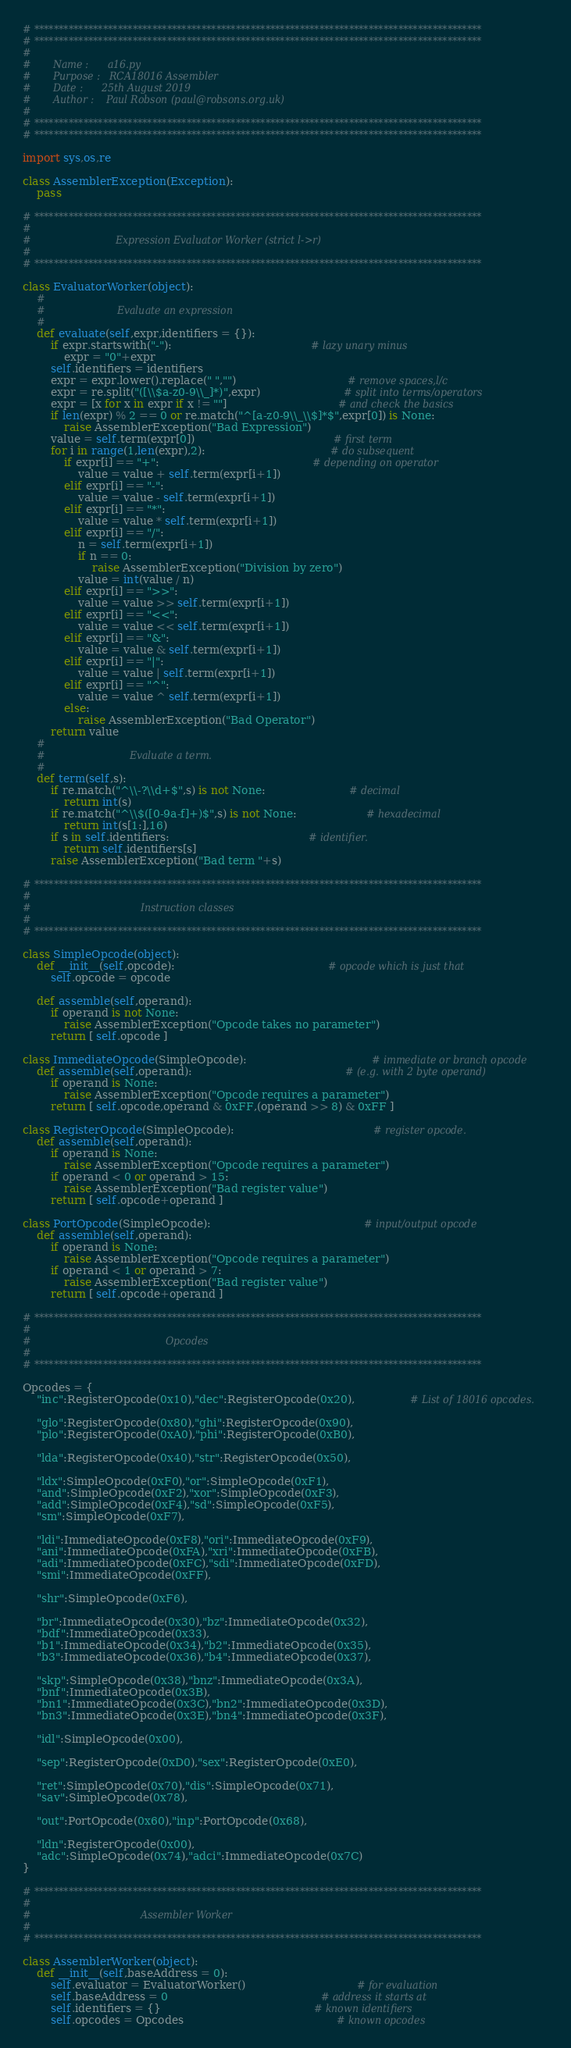Convert code to text. <code><loc_0><loc_0><loc_500><loc_500><_Python_># *******************************************************************************************
# *******************************************************************************************
#
#		Name : 		a16.py
#		Purpose :	RCA18016 Assembler
#		Date :		25th August 2019
#		Author : 	Paul Robson (paul@robsons.org.uk)
#
# *******************************************************************************************
# *******************************************************************************************

import sys,os,re

class AssemblerException(Exception):
	pass

# *******************************************************************************************
#
#							Expression Evaluator Worker (strict l->r)
#
# *******************************************************************************************

class EvaluatorWorker(object):
	#
	#						Evaluate an expression
	#
	def evaluate(self,expr,identifiers = {}):
		if expr.startswith("-"):										# lazy unary minus
			expr = "0"+expr
		self.identifiers = identifiers
		expr = expr.lower().replace(" ","")								# remove spaces,l/c
		expr = re.split("([\\$a-z0-9\\_]*)",expr)						# split into terms/operators
		expr = [x for x in expr if x != ""]								# and check the basics
		if len(expr) % 2 == 0 or re.match("^[a-z0-9\\_\\$]*$",expr[0]) is None:
			raise AssemblerException("Bad Expression")
		value = self.term(expr[0])										# first term
		for i in range(1,len(expr),2):									# do subsequent
			if expr[i] == "+":											# depending on operator
				value = value + self.term(expr[i+1])
			elif expr[i] == "-":
				value = value - self.term(expr[i+1])
			elif expr[i] == "*":
				value = value * self.term(expr[i+1])
			elif expr[i] == "/":
				n = self.term(expr[i+1])
				if n == 0:
					raise AssemblerException("Division by zero")
				value = int(value / n)
			elif expr[i] == ">>":
				value = value >> self.term(expr[i+1])
			elif expr[i] == "<<":
				value = value << self.term(expr[i+1])
			elif expr[i] == "&":
				value = value & self.term(expr[i+1])
			elif expr[i] == "|":
				value = value | self.term(expr[i+1])
			elif expr[i] == "^":
				value = value ^ self.term(expr[i+1])
			else:
				raise AssemblerException("Bad Operator")
		return value
	#
	#							Evaluate a term.
	#
	def term(self,s):
		if re.match("^\\-?\\d+$",s) is not None:						# decimal
			return int(s)
		if re.match("^\\$([0-9a-f]+)$",s) is not None: 					# hexadecimal
			return int(s[1:],16)
		if s in self.identifiers:										# identifier.
			return self.identifiers[s]
		raise AssemblerException("Bad term "+s)

# *******************************************************************************************
#
#									Instruction classes
#
# *******************************************************************************************

class SimpleOpcode(object):
	def __init__(self,opcode):											# opcode which is just that
		self.opcode = opcode

	def assemble(self,operand):
		if operand is not None:
			raise AssemblerException("Opcode takes no parameter")
		return [ self.opcode ]

class ImmediateOpcode(SimpleOpcode):									# immediate or branch opcode
	def assemble(self,operand):											# (e.g. with 2 byte operand)
		if operand is None:
			raise AssemblerException("Opcode requires a parameter")		
		return [ self.opcode,operand & 0xFF,(operand >> 8) & 0xFF ]

class RegisterOpcode(SimpleOpcode):										# register opcode.
	def assemble(self,operand):
		if operand is None:
			raise AssemblerException("Opcode requires a parameter")		
		if operand < 0 or operand > 15:
			raise AssemblerException("Bad register value")
		return [ self.opcode+operand ]

class PortOpcode(SimpleOpcode):											# input/output opcode
	def assemble(self,operand):
		if operand is None:
			raise AssemblerException("Opcode requires a parameter")		
		if operand < 1 or operand > 7:
			raise AssemblerException("Bad register value")
		return [ self.opcode+operand ]

# *******************************************************************************************
#
#											Opcodes
#
# *******************************************************************************************

Opcodes = {
	"inc":RegisterOpcode(0x10),"dec":RegisterOpcode(0x20),				# List of 18016 opcodes.

	"glo":RegisterOpcode(0x80),"ghi":RegisterOpcode(0x90),
	"plo":RegisterOpcode(0xA0),"phi":RegisterOpcode(0xB0),

	"lda":RegisterOpcode(0x40),"str":RegisterOpcode(0x50),

	"ldx":SimpleOpcode(0xF0),"or":SimpleOpcode(0xF1),
	"and":SimpleOpcode(0xF2),"xor":SimpleOpcode(0xF3),
	"add":SimpleOpcode(0xF4),"sd":SimpleOpcode(0xF5),
	"sm":SimpleOpcode(0xF7),

	"ldi":ImmediateOpcode(0xF8),"ori":ImmediateOpcode(0xF9),
	"ani":ImmediateOpcode(0xFA),"xri":ImmediateOpcode(0xFB),
	"adi":ImmediateOpcode(0xFC),"sdi":ImmediateOpcode(0xFD),
	"smi":ImmediateOpcode(0xFF),

	"shr":SimpleOpcode(0xF6),

	"br":ImmediateOpcode(0x30),"bz":ImmediateOpcode(0x32),
	"bdf":ImmediateOpcode(0x33),
	"b1":ImmediateOpcode(0x34),"b2":ImmediateOpcode(0x35),
	"b3":ImmediateOpcode(0x36),"b4":ImmediateOpcode(0x37),

	"skp":SimpleOpcode(0x38),"bnz":ImmediateOpcode(0x3A),
	"bnf":ImmediateOpcode(0x3B),
	"bn1":ImmediateOpcode(0x3C),"bn2":ImmediateOpcode(0x3D),
	"bn3":ImmediateOpcode(0x3E),"bn4":ImmediateOpcode(0x3F),

	"idl":SimpleOpcode(0x00),

	"sep":RegisterOpcode(0xD0),"sex":RegisterOpcode(0xE0),

	"ret":SimpleOpcode(0x70),"dis":SimpleOpcode(0x71),
	"sav":SimpleOpcode(0x78),

	"out":PortOpcode(0x60),"inp":PortOpcode(0x68),

	"ldn":RegisterOpcode(0x00),	
	"adc":SimpleOpcode(0x74),"adci":ImmediateOpcode(0x7C)
}

# *******************************************************************************************
#
#									Assembler Worker
#
# *******************************************************************************************

class AssemblerWorker(object):
	def __init__(self,baseAddress = 0):
		self.evaluator = EvaluatorWorker()								# for evaluation
		self.baseAddress = 0 											# address it starts at
		self.identifiers = {}											# known identifiers
		self.opcodes = Opcodes 											# known opcodes</code> 